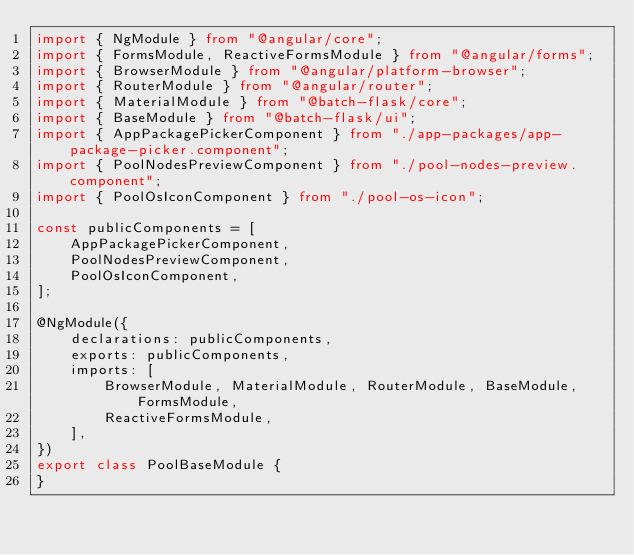Convert code to text. <code><loc_0><loc_0><loc_500><loc_500><_TypeScript_>import { NgModule } from "@angular/core";
import { FormsModule, ReactiveFormsModule } from "@angular/forms";
import { BrowserModule } from "@angular/platform-browser";
import { RouterModule } from "@angular/router";
import { MaterialModule } from "@batch-flask/core";
import { BaseModule } from "@batch-flask/ui";
import { AppPackagePickerComponent } from "./app-packages/app-package-picker.component";
import { PoolNodesPreviewComponent } from "./pool-nodes-preview.component";
import { PoolOsIconComponent } from "./pool-os-icon";

const publicComponents = [
    AppPackagePickerComponent,
    PoolNodesPreviewComponent,
    PoolOsIconComponent,
];

@NgModule({
    declarations: publicComponents,
    exports: publicComponents,
    imports: [
        BrowserModule, MaterialModule, RouterModule, BaseModule, FormsModule,
        ReactiveFormsModule,
    ],
})
export class PoolBaseModule {
}
</code> 